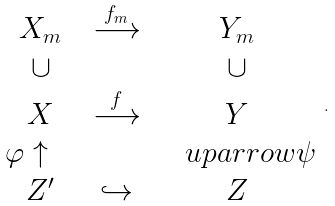Convert formula to latex. <formula><loc_0><loc_0><loc_500><loc_500>\begin{array} { c c c } X _ { m } & \stackrel { f _ { m } } \longrightarrow & Y _ { m } \\ \cup & & \cup \\ X & \stackrel { f } \longrightarrow & Y \\ \varphi \uparrow \quad & & \quad u p a r r o w \psi \\ Z ^ { \prime } & \hookrightarrow & Z \\ \end{array} .</formula> 